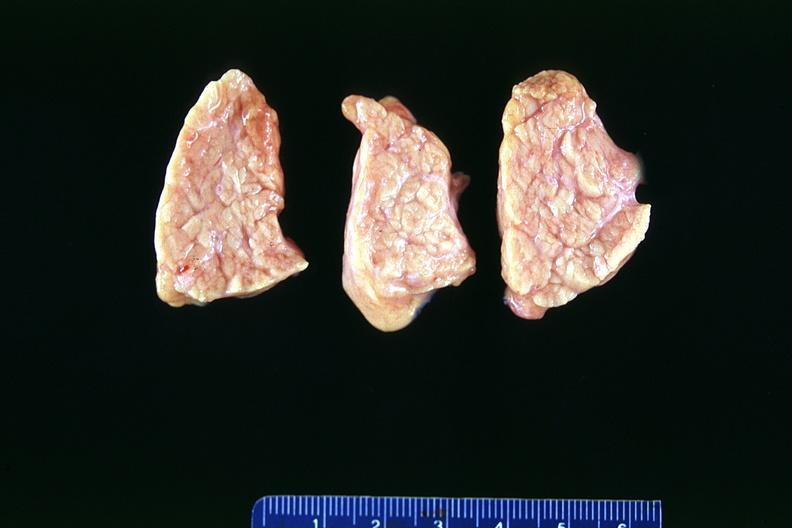does lewy body show normal pancreas?
Answer the question using a single word or phrase. No 